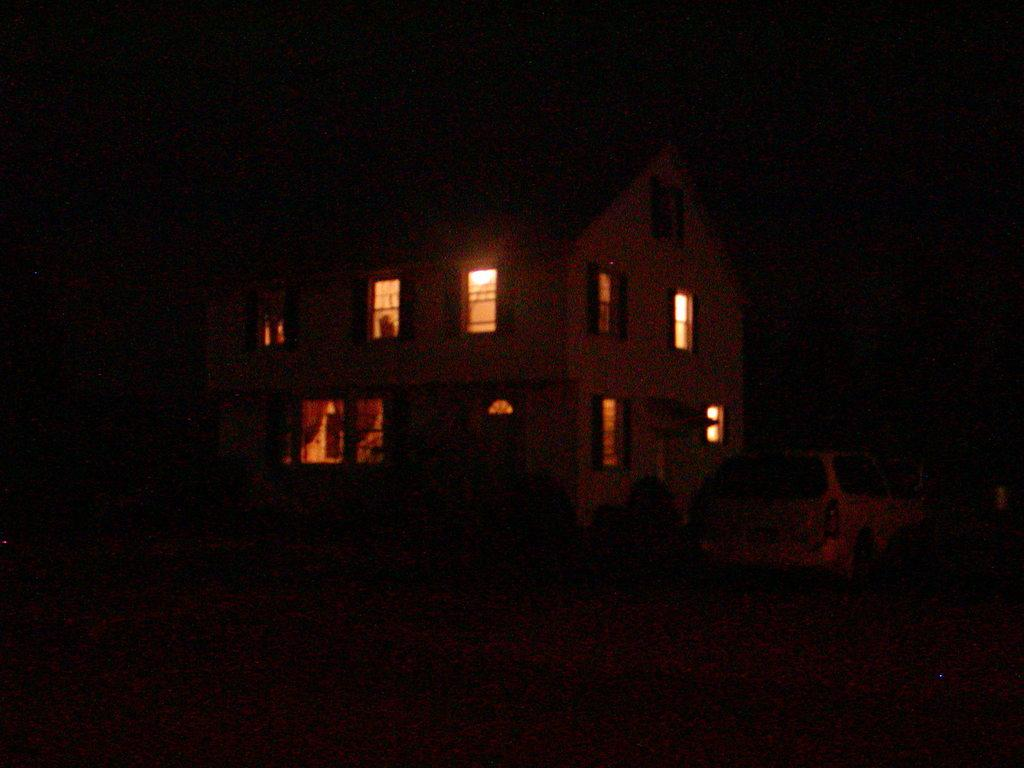What type of structure is visible in the image? There is a house in the image. Can you describe any specific features of the house? There is a window visible in the image. What else can be seen on the ground in the image? There is a car on the ground in the image. How would you describe the lighting in the image? The image appears to be dark. How many bananas are hanging from the window in the image? There are no bananas present in the image; only a house, a window, a car, and the dark lighting can be observed. Can you tell me how many lizards are crawling on the car in the image? There are no lizards present in the image; only a house, a window, a car, and the dark lighting can be observed. 